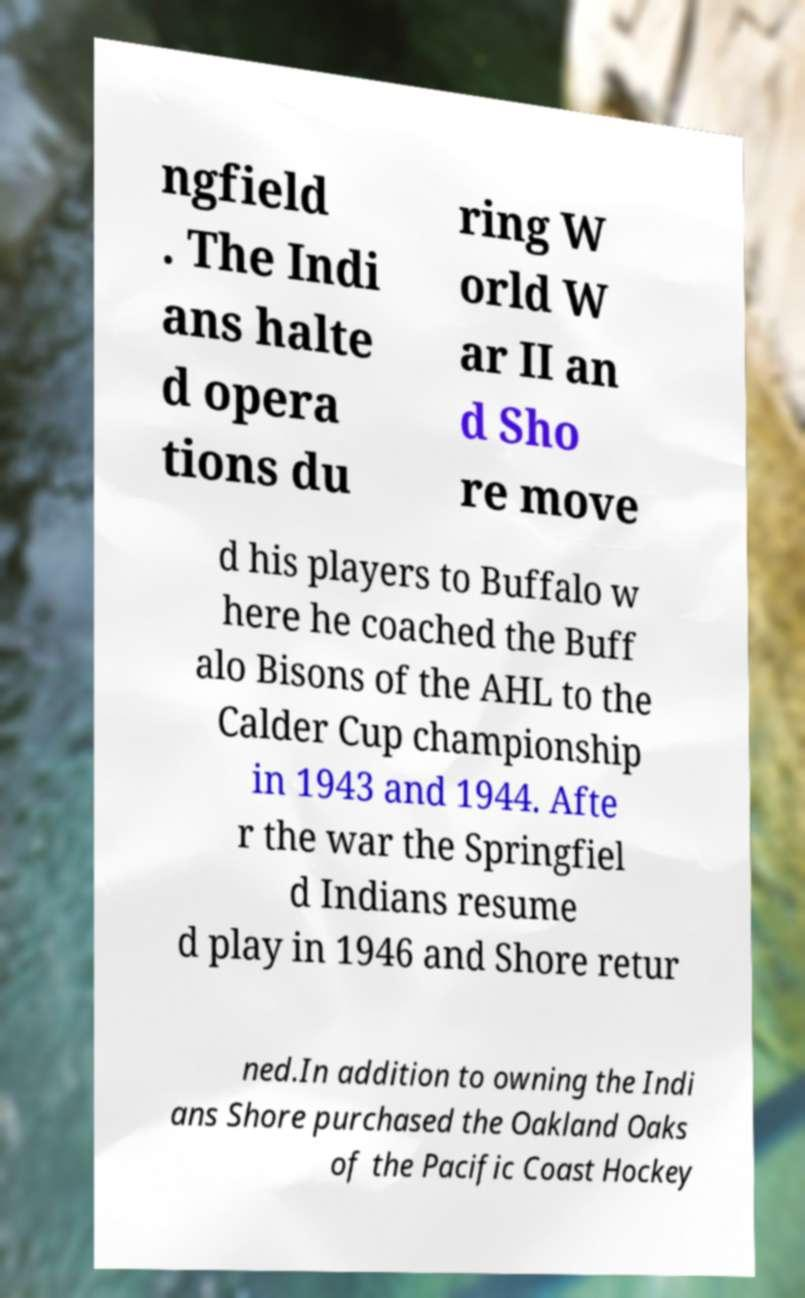What messages or text are displayed in this image? I need them in a readable, typed format. ngfield . The Indi ans halte d opera tions du ring W orld W ar II an d Sho re move d his players to Buffalo w here he coached the Buff alo Bisons of the AHL to the Calder Cup championship in 1943 and 1944. Afte r the war the Springfiel d Indians resume d play in 1946 and Shore retur ned.In addition to owning the Indi ans Shore purchased the Oakland Oaks of the Pacific Coast Hockey 